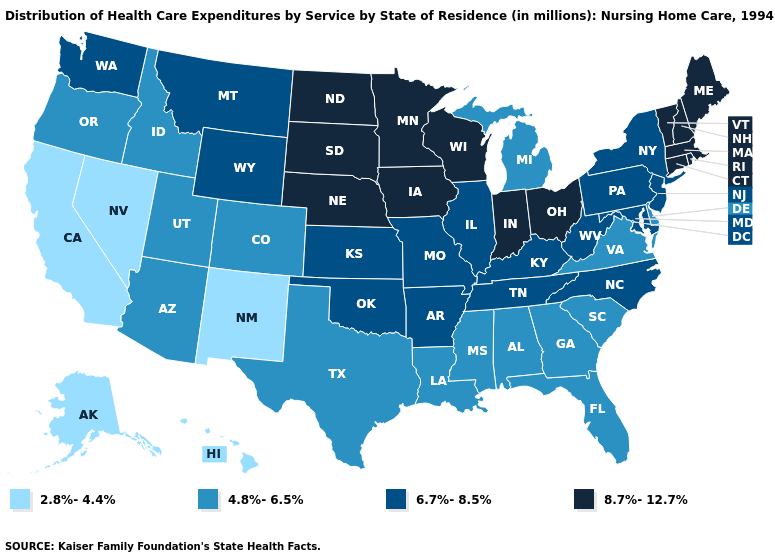What is the value of California?
Give a very brief answer. 2.8%-4.4%. Does New Hampshire have the lowest value in the USA?
Concise answer only. No. How many symbols are there in the legend?
Quick response, please. 4. Which states hav the highest value in the South?
Concise answer only. Arkansas, Kentucky, Maryland, North Carolina, Oklahoma, Tennessee, West Virginia. What is the value of Utah?
Quick response, please. 4.8%-6.5%. Among the states that border Nevada , which have the highest value?
Quick response, please. Arizona, Idaho, Oregon, Utah. What is the highest value in the USA?
Give a very brief answer. 8.7%-12.7%. Among the states that border Connecticut , which have the lowest value?
Keep it brief. New York. Name the states that have a value in the range 8.7%-12.7%?
Quick response, please. Connecticut, Indiana, Iowa, Maine, Massachusetts, Minnesota, Nebraska, New Hampshire, North Dakota, Ohio, Rhode Island, South Dakota, Vermont, Wisconsin. What is the highest value in the USA?
Write a very short answer. 8.7%-12.7%. Which states hav the highest value in the Northeast?
Short answer required. Connecticut, Maine, Massachusetts, New Hampshire, Rhode Island, Vermont. Name the states that have a value in the range 8.7%-12.7%?
Concise answer only. Connecticut, Indiana, Iowa, Maine, Massachusetts, Minnesota, Nebraska, New Hampshire, North Dakota, Ohio, Rhode Island, South Dakota, Vermont, Wisconsin. What is the value of Kentucky?
Write a very short answer. 6.7%-8.5%. What is the value of Rhode Island?
Write a very short answer. 8.7%-12.7%. 